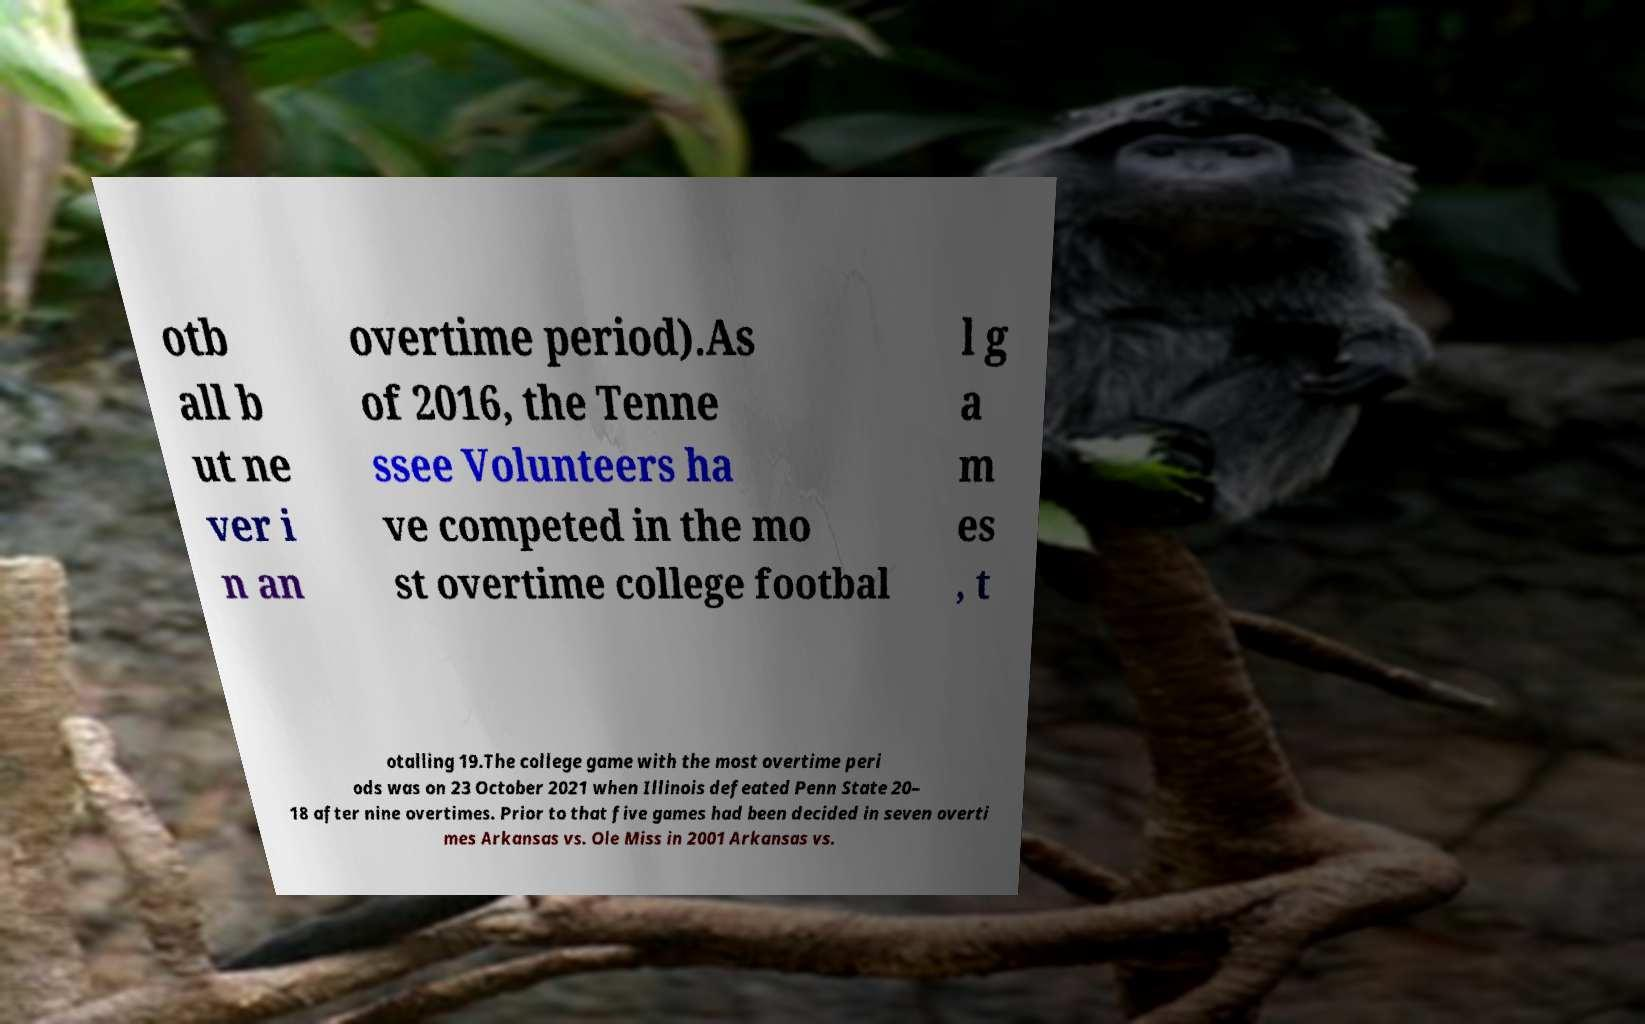For documentation purposes, I need the text within this image transcribed. Could you provide that? otb all b ut ne ver i n an overtime period).As of 2016, the Tenne ssee Volunteers ha ve competed in the mo st overtime college footbal l g a m es , t otalling 19.The college game with the most overtime peri ods was on 23 October 2021 when Illinois defeated Penn State 20– 18 after nine overtimes. Prior to that five games had been decided in seven overti mes Arkansas vs. Ole Miss in 2001 Arkansas vs. 